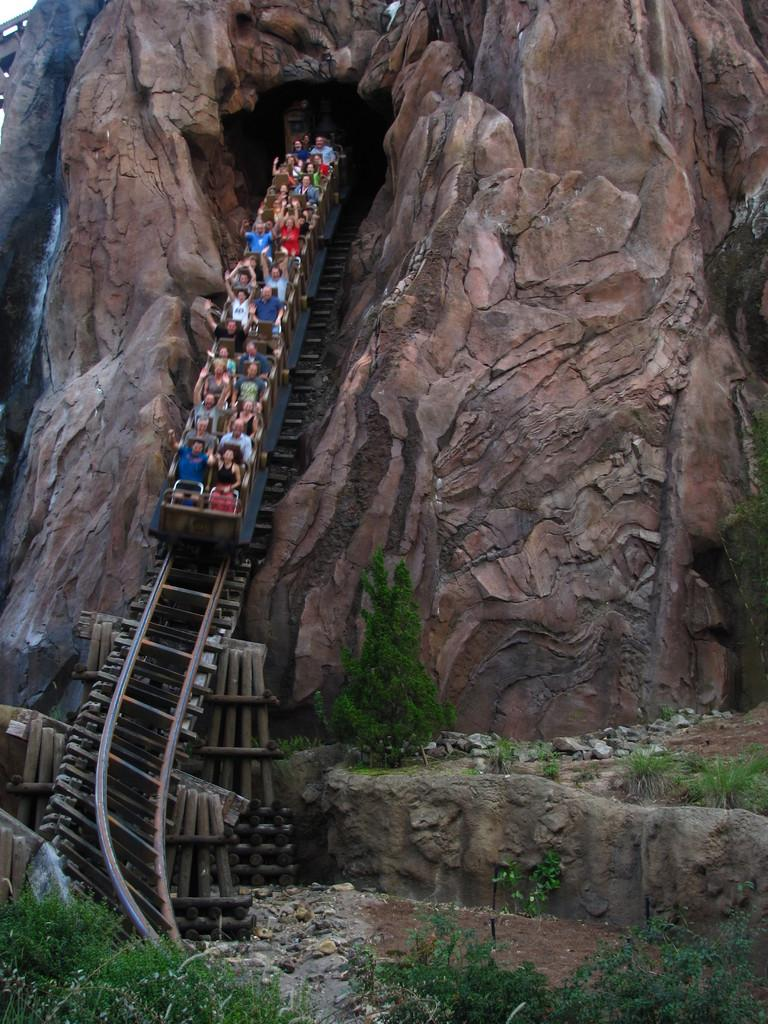What are the people in the image doing? The people in the image are riding. What can be seen on the ground in the image? There are stones and rocks on the ground, as well as plants and other objects. Can you describe the plants in the image? The provided facts do not give specific details about the plants, so we cannot describe them. What type of lock is being used to secure the grip on the plough in the image? There is no lock, grip, or plough present in the image. 